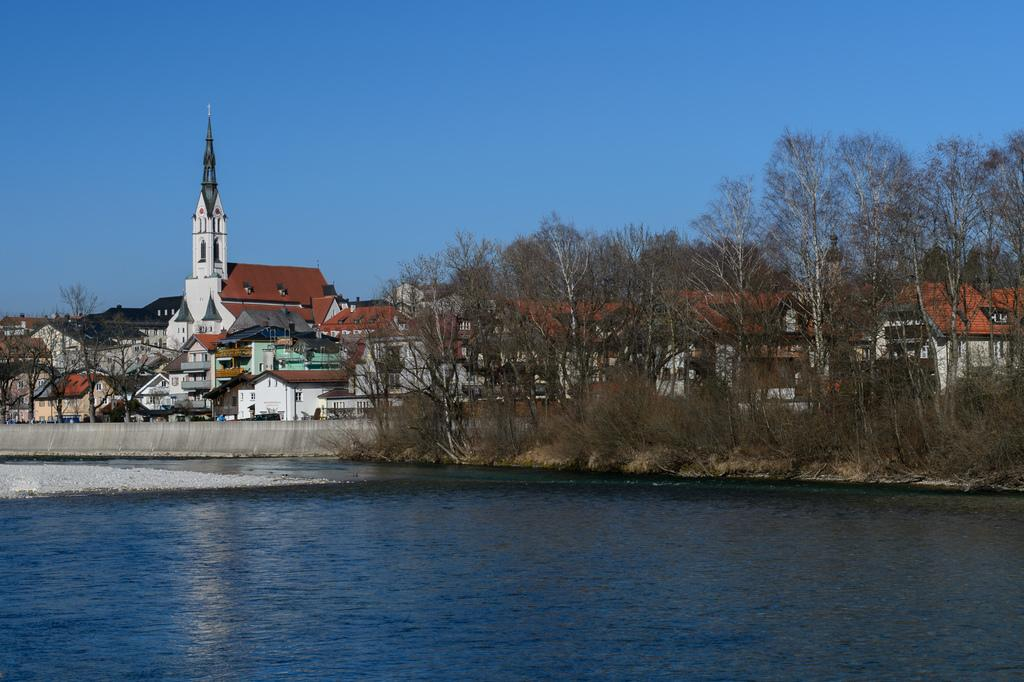What is the main structure in the image? There is a tower in the image. What other man-made structures can be seen in the image? There are buildings in the image. What type of natural vegetation is present in the image? There are trees in the image. What type of barrier is visible in the image? There is a wall in the image. What type of natural water body is present in the image? There is a lake in the image. What is visible in the sky in the image? The sky is visible in the image. Can you see a patch of hair on the tower in the image? There is no patch of hair present on the tower in the image. What book is the tower holding in the image? There is no book present in the image. 